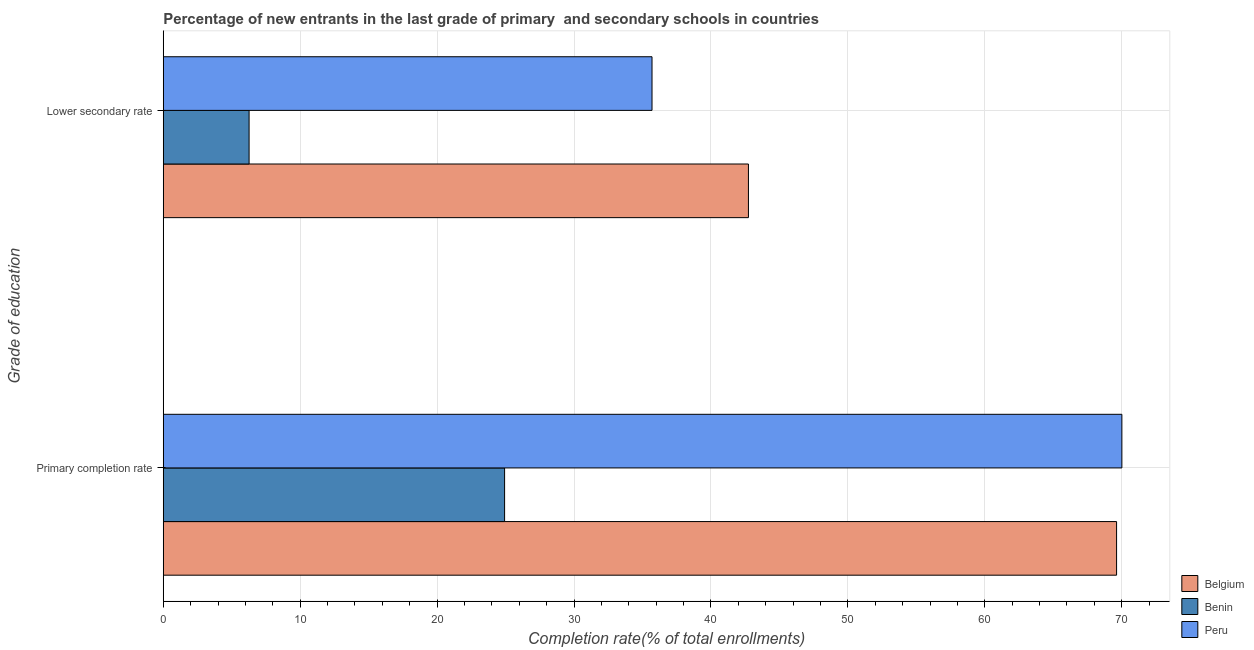How many different coloured bars are there?
Make the answer very short. 3. Are the number of bars per tick equal to the number of legend labels?
Keep it short and to the point. Yes. How many bars are there on the 2nd tick from the top?
Your answer should be very brief. 3. What is the label of the 1st group of bars from the top?
Your answer should be very brief. Lower secondary rate. What is the completion rate in secondary schools in Benin?
Your answer should be very brief. 6.27. Across all countries, what is the maximum completion rate in secondary schools?
Give a very brief answer. 42.74. Across all countries, what is the minimum completion rate in secondary schools?
Make the answer very short. 6.27. In which country was the completion rate in primary schools minimum?
Ensure brevity in your answer.  Benin. What is the total completion rate in primary schools in the graph?
Your response must be concise. 164.56. What is the difference between the completion rate in secondary schools in Peru and that in Benin?
Your answer should be compact. 29.43. What is the difference between the completion rate in secondary schools in Belgium and the completion rate in primary schools in Peru?
Offer a very short reply. -27.27. What is the average completion rate in secondary schools per country?
Ensure brevity in your answer.  28.23. What is the difference between the completion rate in secondary schools and completion rate in primary schools in Benin?
Your response must be concise. -18.66. In how many countries, is the completion rate in secondary schools greater than 66 %?
Provide a succinct answer. 0. What is the ratio of the completion rate in secondary schools in Peru to that in Benin?
Make the answer very short. 5.69. Is the completion rate in primary schools in Peru less than that in Belgium?
Your answer should be compact. No. In how many countries, is the completion rate in primary schools greater than the average completion rate in primary schools taken over all countries?
Your response must be concise. 2. What does the 2nd bar from the top in Lower secondary rate represents?
Offer a very short reply. Benin. How many countries are there in the graph?
Give a very brief answer. 3. Are the values on the major ticks of X-axis written in scientific E-notation?
Your response must be concise. No. Does the graph contain grids?
Give a very brief answer. Yes. Where does the legend appear in the graph?
Your answer should be compact. Bottom right. How many legend labels are there?
Provide a short and direct response. 3. What is the title of the graph?
Provide a succinct answer. Percentage of new entrants in the last grade of primary  and secondary schools in countries. Does "Czech Republic" appear as one of the legend labels in the graph?
Ensure brevity in your answer.  No. What is the label or title of the X-axis?
Keep it short and to the point. Completion rate(% of total enrollments). What is the label or title of the Y-axis?
Provide a short and direct response. Grade of education. What is the Completion rate(% of total enrollments) in Belgium in Primary completion rate?
Your response must be concise. 69.62. What is the Completion rate(% of total enrollments) of Benin in Primary completion rate?
Make the answer very short. 24.93. What is the Completion rate(% of total enrollments) of Peru in Primary completion rate?
Your answer should be very brief. 70.01. What is the Completion rate(% of total enrollments) in Belgium in Lower secondary rate?
Give a very brief answer. 42.74. What is the Completion rate(% of total enrollments) of Benin in Lower secondary rate?
Provide a short and direct response. 6.27. What is the Completion rate(% of total enrollments) of Peru in Lower secondary rate?
Provide a succinct answer. 35.69. Across all Grade of education, what is the maximum Completion rate(% of total enrollments) of Belgium?
Give a very brief answer. 69.62. Across all Grade of education, what is the maximum Completion rate(% of total enrollments) of Benin?
Keep it short and to the point. 24.93. Across all Grade of education, what is the maximum Completion rate(% of total enrollments) in Peru?
Ensure brevity in your answer.  70.01. Across all Grade of education, what is the minimum Completion rate(% of total enrollments) in Belgium?
Offer a very short reply. 42.74. Across all Grade of education, what is the minimum Completion rate(% of total enrollments) of Benin?
Make the answer very short. 6.27. Across all Grade of education, what is the minimum Completion rate(% of total enrollments) in Peru?
Your answer should be very brief. 35.69. What is the total Completion rate(% of total enrollments) in Belgium in the graph?
Offer a very short reply. 112.36. What is the total Completion rate(% of total enrollments) of Benin in the graph?
Your answer should be compact. 31.2. What is the total Completion rate(% of total enrollments) in Peru in the graph?
Give a very brief answer. 105.7. What is the difference between the Completion rate(% of total enrollments) of Belgium in Primary completion rate and that in Lower secondary rate?
Provide a succinct answer. 26.89. What is the difference between the Completion rate(% of total enrollments) in Benin in Primary completion rate and that in Lower secondary rate?
Your response must be concise. 18.66. What is the difference between the Completion rate(% of total enrollments) in Peru in Primary completion rate and that in Lower secondary rate?
Keep it short and to the point. 34.31. What is the difference between the Completion rate(% of total enrollments) in Belgium in Primary completion rate and the Completion rate(% of total enrollments) in Benin in Lower secondary rate?
Provide a short and direct response. 63.36. What is the difference between the Completion rate(% of total enrollments) of Belgium in Primary completion rate and the Completion rate(% of total enrollments) of Peru in Lower secondary rate?
Provide a succinct answer. 33.93. What is the difference between the Completion rate(% of total enrollments) in Benin in Primary completion rate and the Completion rate(% of total enrollments) in Peru in Lower secondary rate?
Make the answer very short. -10.77. What is the average Completion rate(% of total enrollments) in Belgium per Grade of education?
Keep it short and to the point. 56.18. What is the average Completion rate(% of total enrollments) in Benin per Grade of education?
Offer a very short reply. 15.6. What is the average Completion rate(% of total enrollments) in Peru per Grade of education?
Keep it short and to the point. 52.85. What is the difference between the Completion rate(% of total enrollments) of Belgium and Completion rate(% of total enrollments) of Benin in Primary completion rate?
Provide a succinct answer. 44.7. What is the difference between the Completion rate(% of total enrollments) of Belgium and Completion rate(% of total enrollments) of Peru in Primary completion rate?
Provide a short and direct response. -0.39. What is the difference between the Completion rate(% of total enrollments) of Benin and Completion rate(% of total enrollments) of Peru in Primary completion rate?
Offer a terse response. -45.08. What is the difference between the Completion rate(% of total enrollments) of Belgium and Completion rate(% of total enrollments) of Benin in Lower secondary rate?
Provide a short and direct response. 36.47. What is the difference between the Completion rate(% of total enrollments) in Belgium and Completion rate(% of total enrollments) in Peru in Lower secondary rate?
Your answer should be compact. 7.04. What is the difference between the Completion rate(% of total enrollments) in Benin and Completion rate(% of total enrollments) in Peru in Lower secondary rate?
Make the answer very short. -29.43. What is the ratio of the Completion rate(% of total enrollments) in Belgium in Primary completion rate to that in Lower secondary rate?
Give a very brief answer. 1.63. What is the ratio of the Completion rate(% of total enrollments) in Benin in Primary completion rate to that in Lower secondary rate?
Your answer should be compact. 3.98. What is the ratio of the Completion rate(% of total enrollments) of Peru in Primary completion rate to that in Lower secondary rate?
Your answer should be very brief. 1.96. What is the difference between the highest and the second highest Completion rate(% of total enrollments) of Belgium?
Provide a succinct answer. 26.89. What is the difference between the highest and the second highest Completion rate(% of total enrollments) in Benin?
Offer a very short reply. 18.66. What is the difference between the highest and the second highest Completion rate(% of total enrollments) of Peru?
Keep it short and to the point. 34.31. What is the difference between the highest and the lowest Completion rate(% of total enrollments) in Belgium?
Keep it short and to the point. 26.89. What is the difference between the highest and the lowest Completion rate(% of total enrollments) in Benin?
Your response must be concise. 18.66. What is the difference between the highest and the lowest Completion rate(% of total enrollments) in Peru?
Your answer should be compact. 34.31. 